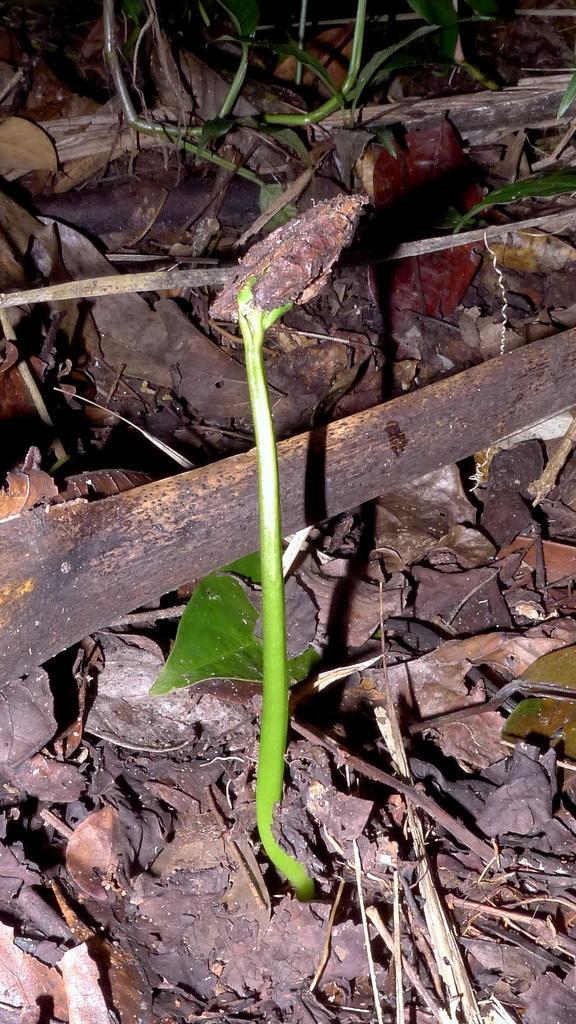How would you summarize this image in a sentence or two? In this picture I can see small growing plant, beside that I can see the leaves and wooden sticks. 